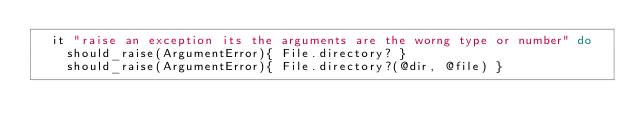<code> <loc_0><loc_0><loc_500><loc_500><_Ruby_>  it "raise an exception its the arguments are the worng type or number" do
    should_raise(ArgumentError){ File.directory? }
    should_raise(ArgumentError){ File.directory?(@dir, @file) }</code> 